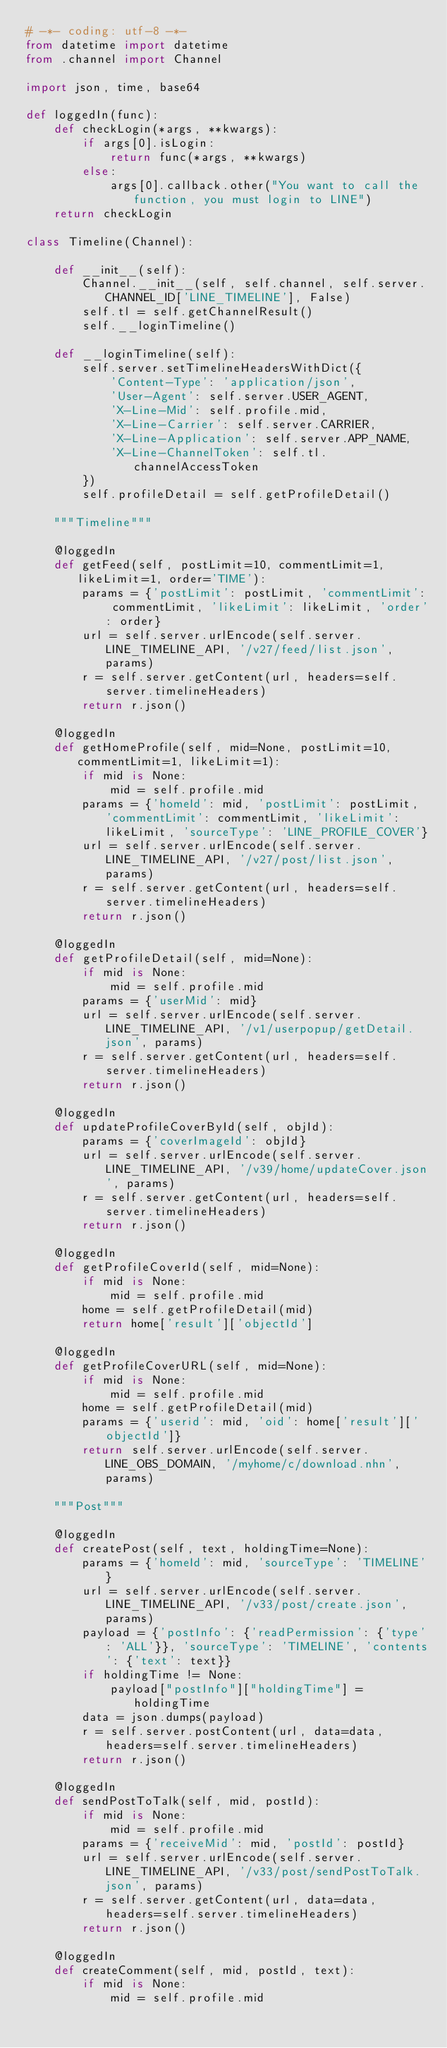<code> <loc_0><loc_0><loc_500><loc_500><_Python_># -*- coding: utf-8 -*-
from datetime import datetime
from .channel import Channel

import json, time, base64

def loggedIn(func):
    def checkLogin(*args, **kwargs):
        if args[0].isLogin:
            return func(*args, **kwargs)
        else:
            args[0].callback.other("You want to call the function, you must login to LINE")
    return checkLogin
    
class Timeline(Channel):

    def __init__(self):
        Channel.__init__(self, self.channel, self.server.CHANNEL_ID['LINE_TIMELINE'], False)
        self.tl = self.getChannelResult()
        self.__loginTimeline()
        
    def __loginTimeline(self):
        self.server.setTimelineHeadersWithDict({
            'Content-Type': 'application/json',
            'User-Agent': self.server.USER_AGENT,
            'X-Line-Mid': self.profile.mid,
            'X-Line-Carrier': self.server.CARRIER,
            'X-Line-Application': self.server.APP_NAME,
            'X-Line-ChannelToken': self.tl.channelAccessToken
        })
        self.profileDetail = self.getProfileDetail()

    """Timeline"""

    @loggedIn
    def getFeed(self, postLimit=10, commentLimit=1, likeLimit=1, order='TIME'):
        params = {'postLimit': postLimit, 'commentLimit': commentLimit, 'likeLimit': likeLimit, 'order': order}
        url = self.server.urlEncode(self.server.LINE_TIMELINE_API, '/v27/feed/list.json', params)
        r = self.server.getContent(url, headers=self.server.timelineHeaders)
        return r.json()

    @loggedIn
    def getHomeProfile(self, mid=None, postLimit=10, commentLimit=1, likeLimit=1):
        if mid is None:
            mid = self.profile.mid
        params = {'homeId': mid, 'postLimit': postLimit, 'commentLimit': commentLimit, 'likeLimit': likeLimit, 'sourceType': 'LINE_PROFILE_COVER'}
        url = self.server.urlEncode(self.server.LINE_TIMELINE_API, '/v27/post/list.json', params)
        r = self.server.getContent(url, headers=self.server.timelineHeaders)
        return r.json()

    @loggedIn
    def getProfileDetail(self, mid=None):
        if mid is None:
            mid = self.profile.mid
        params = {'userMid': mid}
        url = self.server.urlEncode(self.server.LINE_TIMELINE_API, '/v1/userpopup/getDetail.json', params)
        r = self.server.getContent(url, headers=self.server.timelineHeaders)
        return r.json()

    @loggedIn
    def updateProfileCoverById(self, objId):
        params = {'coverImageId': objId}
        url = self.server.urlEncode(self.server.LINE_TIMELINE_API, '/v39/home/updateCover.json', params)
        r = self.server.getContent(url, headers=self.server.timelineHeaders)
        return r.json()

    @loggedIn
    def getProfileCoverId(self, mid=None):
        if mid is None:
            mid = self.profile.mid
        home = self.getProfileDetail(mid)
        return home['result']['objectId']

    @loggedIn
    def getProfileCoverURL(self, mid=None):
        if mid is None:
            mid = self.profile.mid
        home = self.getProfileDetail(mid)
        params = {'userid': mid, 'oid': home['result']['objectId']}
        return self.server.urlEncode(self.server.LINE_OBS_DOMAIN, '/myhome/c/download.nhn', params)

    """Post"""

    @loggedIn
    def createPost(self, text, holdingTime=None):
        params = {'homeId': mid, 'sourceType': 'TIMELINE'}
        url = self.server.urlEncode(self.server.LINE_TIMELINE_API, '/v33/post/create.json', params)
        payload = {'postInfo': {'readPermission': {'type': 'ALL'}}, 'sourceType': 'TIMELINE', 'contents': {'text': text}}
        if holdingTime != None:
            payload["postInfo"]["holdingTime"] = holdingTime
        data = json.dumps(payload)
        r = self.server.postContent(url, data=data, headers=self.server.timelineHeaders)
        return r.json()

    @loggedIn
    def sendPostToTalk(self, mid, postId):
        if mid is None:
            mid = self.profile.mid
        params = {'receiveMid': mid, 'postId': postId}
        url = self.server.urlEncode(self.server.LINE_TIMELINE_API, '/v33/post/sendPostToTalk.json', params)
        r = self.server.getContent(url, data=data, headers=self.server.timelineHeaders)
        return r.json()

    @loggedIn
    def createComment(self, mid, postId, text):
        if mid is None:
            mid = self.profile.mid</code> 